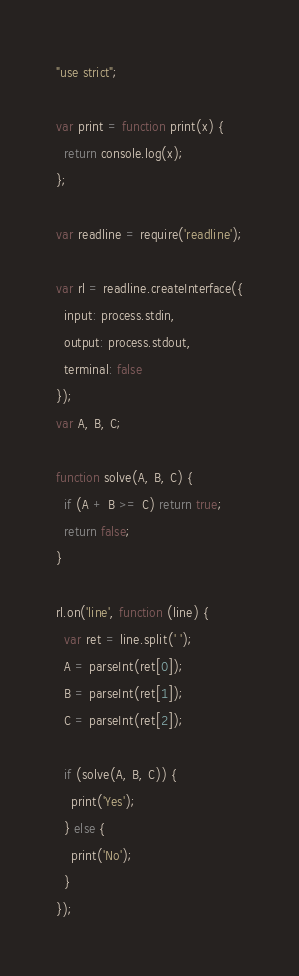<code> <loc_0><loc_0><loc_500><loc_500><_JavaScript_>"use strict";

var print = function print(x) {
  return console.log(x);
};

var readline = require('readline');

var rl = readline.createInterface({
  input: process.stdin,
  output: process.stdout,
  terminal: false
});
var A, B, C;

function solve(A, B, C) {
  if (A + B >= C) return true;
  return false;
}

rl.on('line', function (line) {
  var ret = line.split(' ');
  A = parseInt(ret[0]);
  B = parseInt(ret[1]);
  C = parseInt(ret[2]);

  if (solve(A, B, C)) {
    print('Yes');
  } else {
    print('No');
  }
});
</code> 